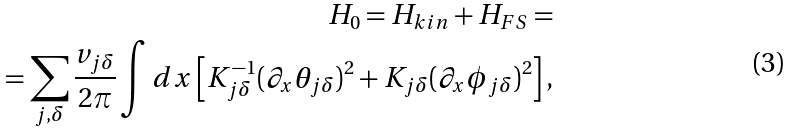<formula> <loc_0><loc_0><loc_500><loc_500>H _ { 0 } = H _ { k i n } + H _ { F S } = \\ = \sum _ { j , \delta } \frac { v _ { j \delta } } { 2 \pi } \int d x \left [ K _ { j \delta } ^ { - 1 } ( \partial _ { x } \theta _ { j \delta } ) ^ { 2 } + K _ { j \delta } ( \partial _ { x } \phi _ { j \delta } ) ^ { 2 } \right ] ,</formula> 